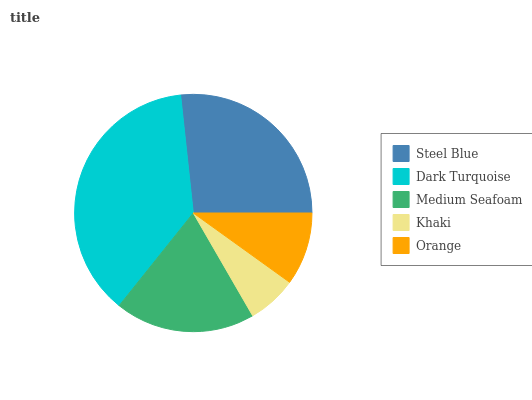Is Khaki the minimum?
Answer yes or no. Yes. Is Dark Turquoise the maximum?
Answer yes or no. Yes. Is Medium Seafoam the minimum?
Answer yes or no. No. Is Medium Seafoam the maximum?
Answer yes or no. No. Is Dark Turquoise greater than Medium Seafoam?
Answer yes or no. Yes. Is Medium Seafoam less than Dark Turquoise?
Answer yes or no. Yes. Is Medium Seafoam greater than Dark Turquoise?
Answer yes or no. No. Is Dark Turquoise less than Medium Seafoam?
Answer yes or no. No. Is Medium Seafoam the high median?
Answer yes or no. Yes. Is Medium Seafoam the low median?
Answer yes or no. Yes. Is Khaki the high median?
Answer yes or no. No. Is Orange the low median?
Answer yes or no. No. 